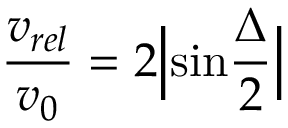Convert formula to latex. <formula><loc_0><loc_0><loc_500><loc_500>{ \frac { v _ { r e l } } { v _ { 0 } } } = 2 \left | \sin { \frac { \Delta } { 2 } } \right |</formula> 